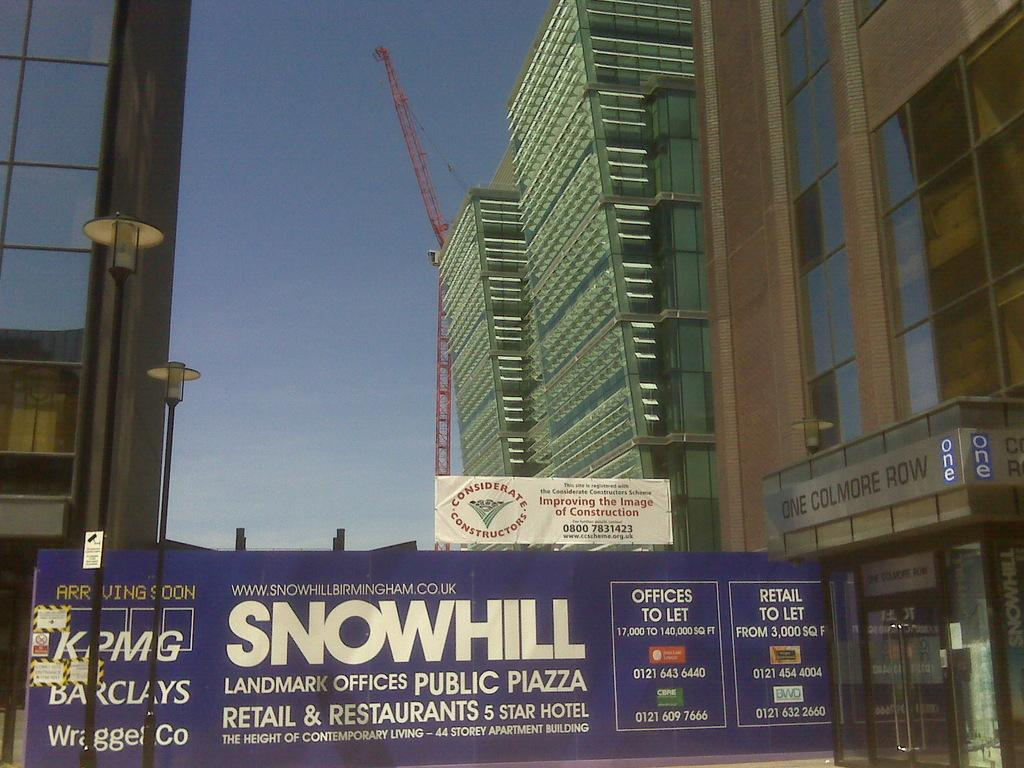What type of structures can be seen in the image? There are buildings in the image. What else can be seen besides the buildings? There are poles, banners, lights, a crane, and glass doors visible in the image. What is the condition of the sky in the background of the image? The sky is clear in the background of the image. What type of pen is being used to write on the quartz in the image? There is no pen or quartz present in the image. What song is being played in the background of the image? There is no song or indication of audio in the image. 